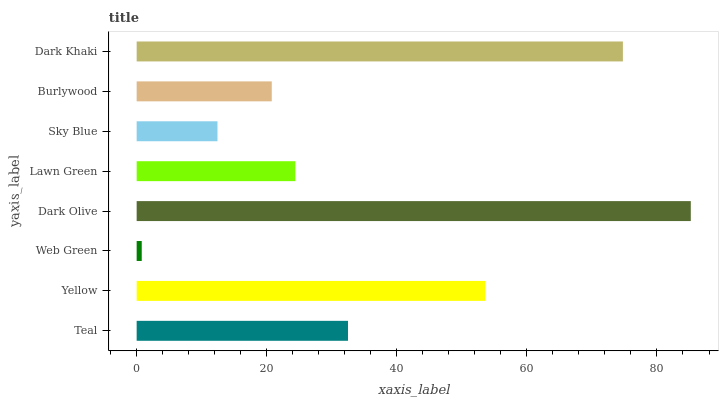Is Web Green the minimum?
Answer yes or no. Yes. Is Dark Olive the maximum?
Answer yes or no. Yes. Is Yellow the minimum?
Answer yes or no. No. Is Yellow the maximum?
Answer yes or no. No. Is Yellow greater than Teal?
Answer yes or no. Yes. Is Teal less than Yellow?
Answer yes or no. Yes. Is Teal greater than Yellow?
Answer yes or no. No. Is Yellow less than Teal?
Answer yes or no. No. Is Teal the high median?
Answer yes or no. Yes. Is Lawn Green the low median?
Answer yes or no. Yes. Is Yellow the high median?
Answer yes or no. No. Is Teal the low median?
Answer yes or no. No. 